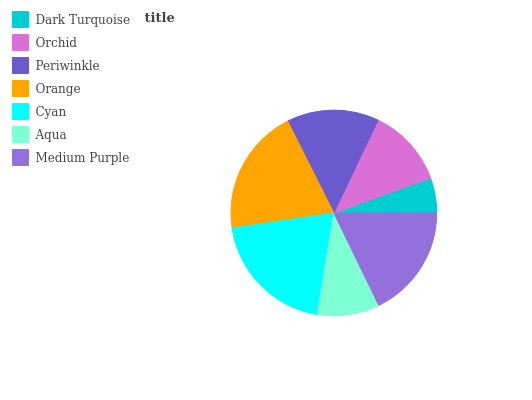Is Dark Turquoise the minimum?
Answer yes or no. Yes. Is Cyan the maximum?
Answer yes or no. Yes. Is Orchid the minimum?
Answer yes or no. No. Is Orchid the maximum?
Answer yes or no. No. Is Orchid greater than Dark Turquoise?
Answer yes or no. Yes. Is Dark Turquoise less than Orchid?
Answer yes or no. Yes. Is Dark Turquoise greater than Orchid?
Answer yes or no. No. Is Orchid less than Dark Turquoise?
Answer yes or no. No. Is Periwinkle the high median?
Answer yes or no. Yes. Is Periwinkle the low median?
Answer yes or no. Yes. Is Dark Turquoise the high median?
Answer yes or no. No. Is Aqua the low median?
Answer yes or no. No. 